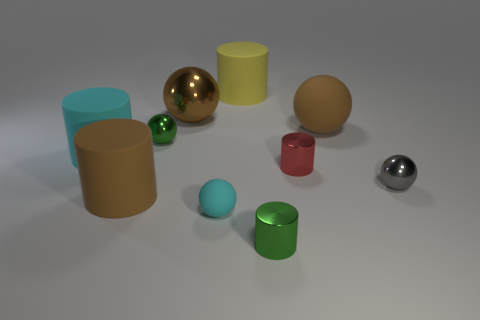Do the tiny gray ball and the red thing have the same material?
Offer a very short reply. Yes. Is the number of brown matte things behind the big brown shiny thing greater than the number of large yellow matte cylinders?
Give a very brief answer. No. How many things are brown rubber cylinders or small metallic spheres that are to the left of the tiny cyan matte ball?
Offer a very short reply. 2. Are there more small gray metallic things behind the red shiny cylinder than metallic cylinders that are behind the yellow object?
Offer a terse response. No. What is the material of the big brown ball that is on the right side of the big object behind the shiny thing behind the large brown rubber ball?
Provide a succinct answer. Rubber. What is the shape of the tiny gray object that is made of the same material as the tiny green sphere?
Your response must be concise. Sphere. There is a metal sphere on the right side of the tiny cyan rubber object; is there a ball that is in front of it?
Keep it short and to the point. Yes. What is the size of the green metal ball?
Your answer should be very brief. Small. How many objects are either brown shiny spheres or small gray things?
Provide a succinct answer. 2. Are the cyan thing that is left of the big brown metallic sphere and the big brown object that is on the right side of the red cylinder made of the same material?
Make the answer very short. Yes. 